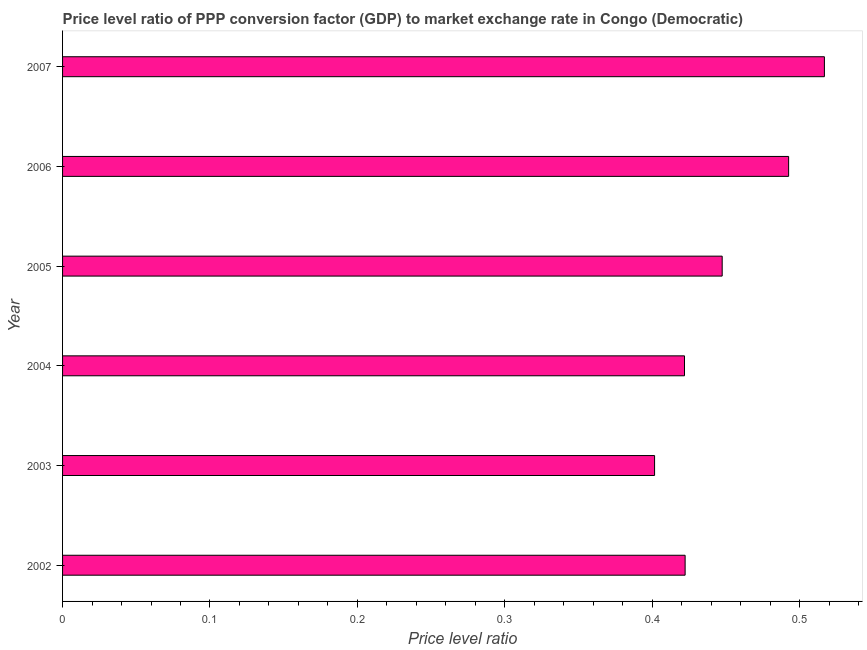Does the graph contain any zero values?
Your answer should be compact. No. Does the graph contain grids?
Offer a terse response. No. What is the title of the graph?
Your answer should be very brief. Price level ratio of PPP conversion factor (GDP) to market exchange rate in Congo (Democratic). What is the label or title of the X-axis?
Your answer should be very brief. Price level ratio. What is the label or title of the Y-axis?
Offer a very short reply. Year. What is the price level ratio in 2004?
Ensure brevity in your answer.  0.42. Across all years, what is the maximum price level ratio?
Keep it short and to the point. 0.52. Across all years, what is the minimum price level ratio?
Your response must be concise. 0.4. In which year was the price level ratio maximum?
Provide a short and direct response. 2007. What is the sum of the price level ratio?
Provide a short and direct response. 2.7. What is the difference between the price level ratio in 2003 and 2004?
Your answer should be compact. -0.02. What is the average price level ratio per year?
Keep it short and to the point. 0.45. What is the median price level ratio?
Offer a very short reply. 0.43. In how many years, is the price level ratio greater than 0.2 ?
Keep it short and to the point. 6. What is the ratio of the price level ratio in 2004 to that in 2007?
Your answer should be compact. 0.82. Is the price level ratio in 2005 less than that in 2006?
Your answer should be compact. Yes. What is the difference between the highest and the second highest price level ratio?
Offer a very short reply. 0.02. What is the difference between the highest and the lowest price level ratio?
Your response must be concise. 0.12. How many bars are there?
Your answer should be compact. 6. Are all the bars in the graph horizontal?
Ensure brevity in your answer.  Yes. What is the difference between two consecutive major ticks on the X-axis?
Provide a short and direct response. 0.1. What is the Price level ratio in 2002?
Your response must be concise. 0.42. What is the Price level ratio in 2003?
Provide a succinct answer. 0.4. What is the Price level ratio of 2004?
Your response must be concise. 0.42. What is the Price level ratio in 2005?
Ensure brevity in your answer.  0.45. What is the Price level ratio of 2006?
Offer a terse response. 0.49. What is the Price level ratio of 2007?
Provide a succinct answer. 0.52. What is the difference between the Price level ratio in 2002 and 2003?
Offer a terse response. 0.02. What is the difference between the Price level ratio in 2002 and 2004?
Your answer should be very brief. 0. What is the difference between the Price level ratio in 2002 and 2005?
Offer a terse response. -0.03. What is the difference between the Price level ratio in 2002 and 2006?
Offer a very short reply. -0.07. What is the difference between the Price level ratio in 2002 and 2007?
Offer a terse response. -0.09. What is the difference between the Price level ratio in 2003 and 2004?
Offer a very short reply. -0.02. What is the difference between the Price level ratio in 2003 and 2005?
Your answer should be very brief. -0.05. What is the difference between the Price level ratio in 2003 and 2006?
Your response must be concise. -0.09. What is the difference between the Price level ratio in 2003 and 2007?
Provide a succinct answer. -0.12. What is the difference between the Price level ratio in 2004 and 2005?
Make the answer very short. -0.03. What is the difference between the Price level ratio in 2004 and 2006?
Your answer should be compact. -0.07. What is the difference between the Price level ratio in 2004 and 2007?
Your answer should be very brief. -0.09. What is the difference between the Price level ratio in 2005 and 2006?
Provide a succinct answer. -0.05. What is the difference between the Price level ratio in 2005 and 2007?
Provide a succinct answer. -0.07. What is the difference between the Price level ratio in 2006 and 2007?
Ensure brevity in your answer.  -0.02. What is the ratio of the Price level ratio in 2002 to that in 2003?
Ensure brevity in your answer.  1.05. What is the ratio of the Price level ratio in 2002 to that in 2005?
Ensure brevity in your answer.  0.94. What is the ratio of the Price level ratio in 2002 to that in 2006?
Make the answer very short. 0.86. What is the ratio of the Price level ratio in 2002 to that in 2007?
Offer a very short reply. 0.82. What is the ratio of the Price level ratio in 2003 to that in 2005?
Offer a terse response. 0.9. What is the ratio of the Price level ratio in 2003 to that in 2006?
Your answer should be compact. 0.81. What is the ratio of the Price level ratio in 2003 to that in 2007?
Offer a terse response. 0.78. What is the ratio of the Price level ratio in 2004 to that in 2005?
Your answer should be very brief. 0.94. What is the ratio of the Price level ratio in 2004 to that in 2006?
Your answer should be compact. 0.86. What is the ratio of the Price level ratio in 2004 to that in 2007?
Ensure brevity in your answer.  0.82. What is the ratio of the Price level ratio in 2005 to that in 2006?
Give a very brief answer. 0.91. What is the ratio of the Price level ratio in 2005 to that in 2007?
Your answer should be very brief. 0.87. What is the ratio of the Price level ratio in 2006 to that in 2007?
Your answer should be very brief. 0.95. 